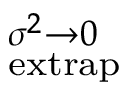Convert formula to latex. <formula><loc_0><loc_0><loc_500><loc_500>^ { \sigma ^ { 2 } \rightarrow 0 } _ { e x t r a p }</formula> 